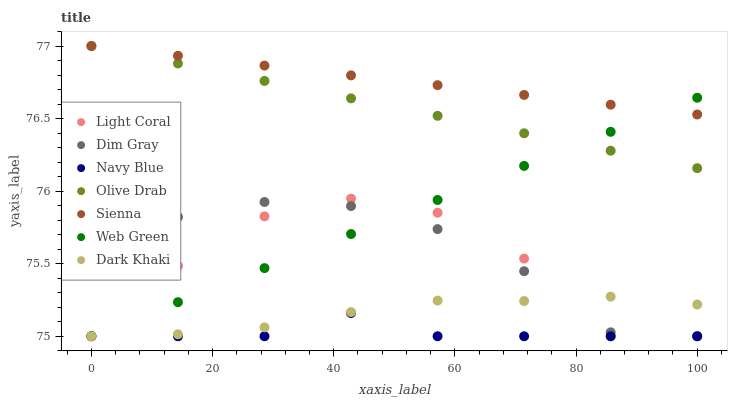Does Navy Blue have the minimum area under the curve?
Answer yes or no. Yes. Does Sienna have the maximum area under the curve?
Answer yes or no. Yes. Does Dim Gray have the minimum area under the curve?
Answer yes or no. No. Does Dim Gray have the maximum area under the curve?
Answer yes or no. No. Is Olive Drab the smoothest?
Answer yes or no. Yes. Is Light Coral the roughest?
Answer yes or no. Yes. Is Dim Gray the smoothest?
Answer yes or no. No. Is Dim Gray the roughest?
Answer yes or no. No. Does Dim Gray have the lowest value?
Answer yes or no. Yes. Does Olive Drab have the lowest value?
Answer yes or no. No. Does Olive Drab have the highest value?
Answer yes or no. Yes. Does Dim Gray have the highest value?
Answer yes or no. No. Is Light Coral less than Olive Drab?
Answer yes or no. Yes. Is Sienna greater than Dark Khaki?
Answer yes or no. Yes. Does Web Green intersect Olive Drab?
Answer yes or no. Yes. Is Web Green less than Olive Drab?
Answer yes or no. No. Is Web Green greater than Olive Drab?
Answer yes or no. No. Does Light Coral intersect Olive Drab?
Answer yes or no. No. 